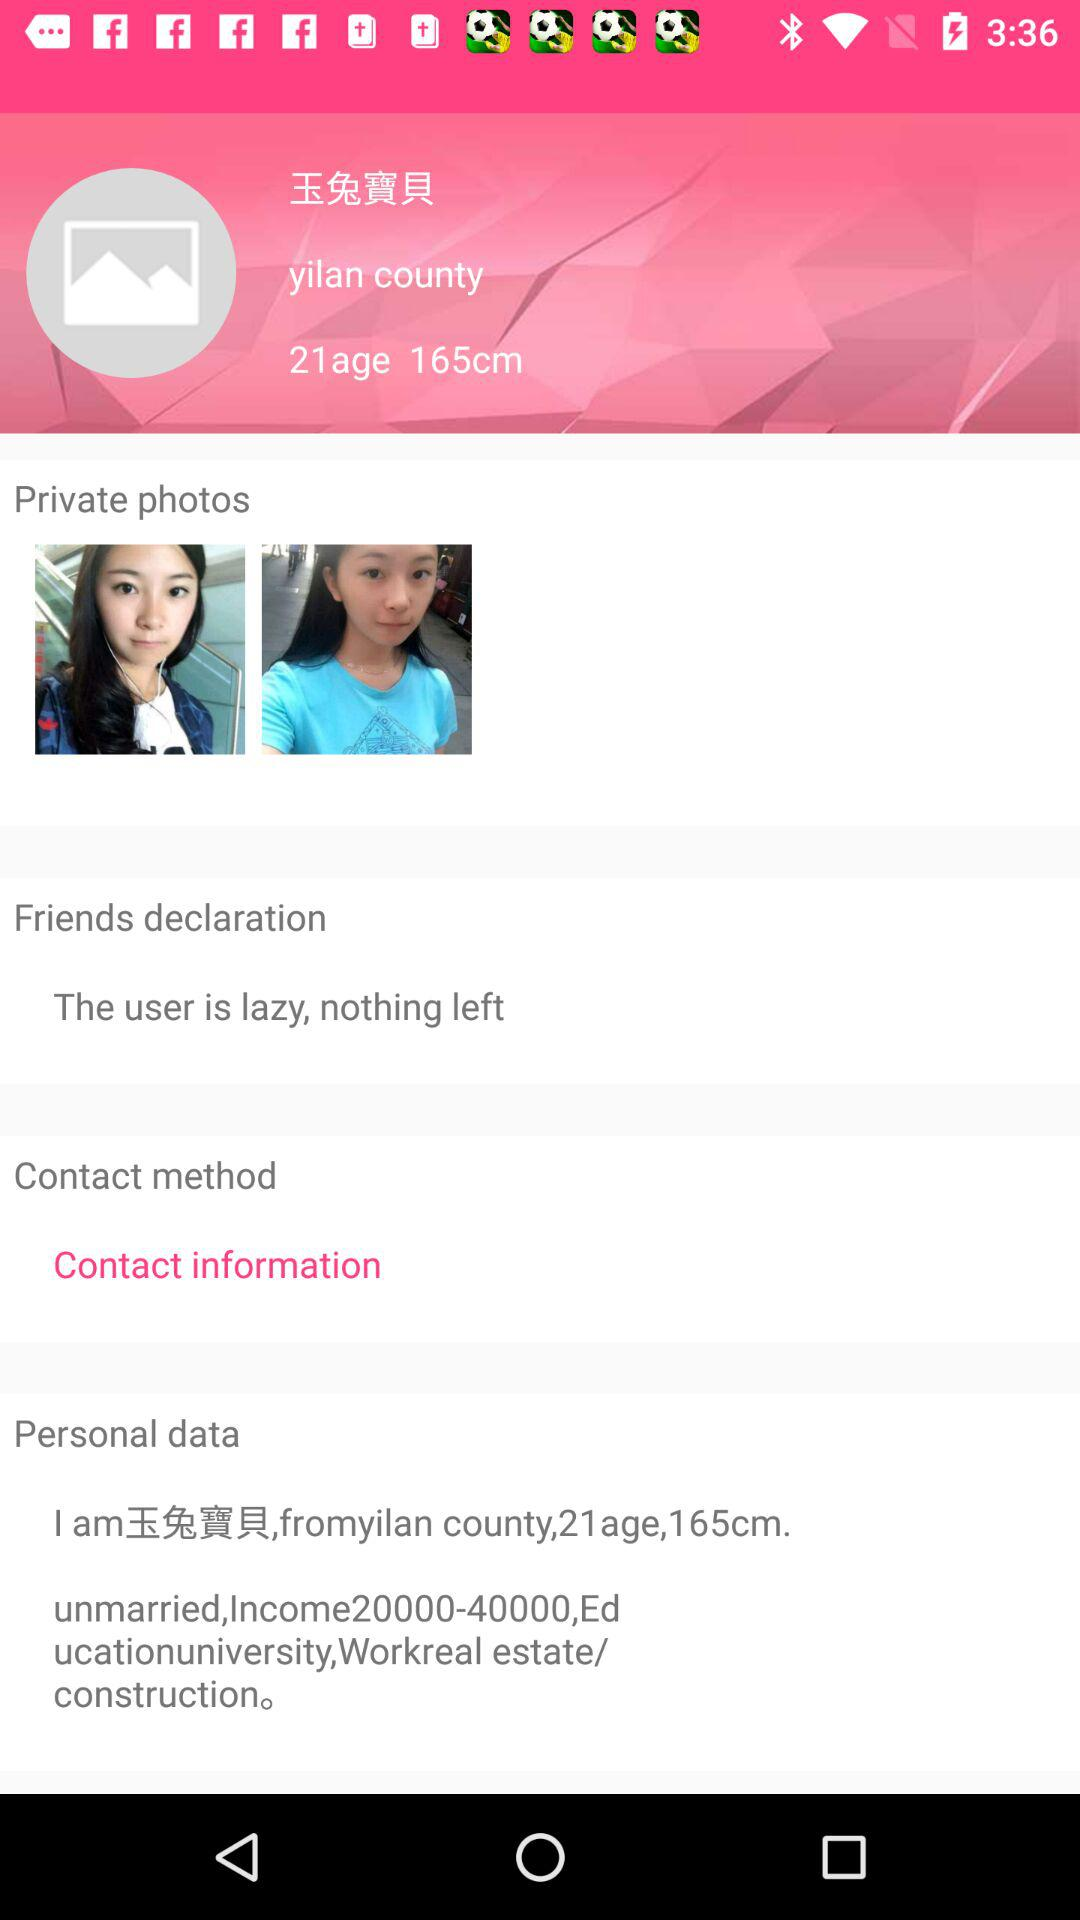What is the marital status? The marital status is "unmarried". 